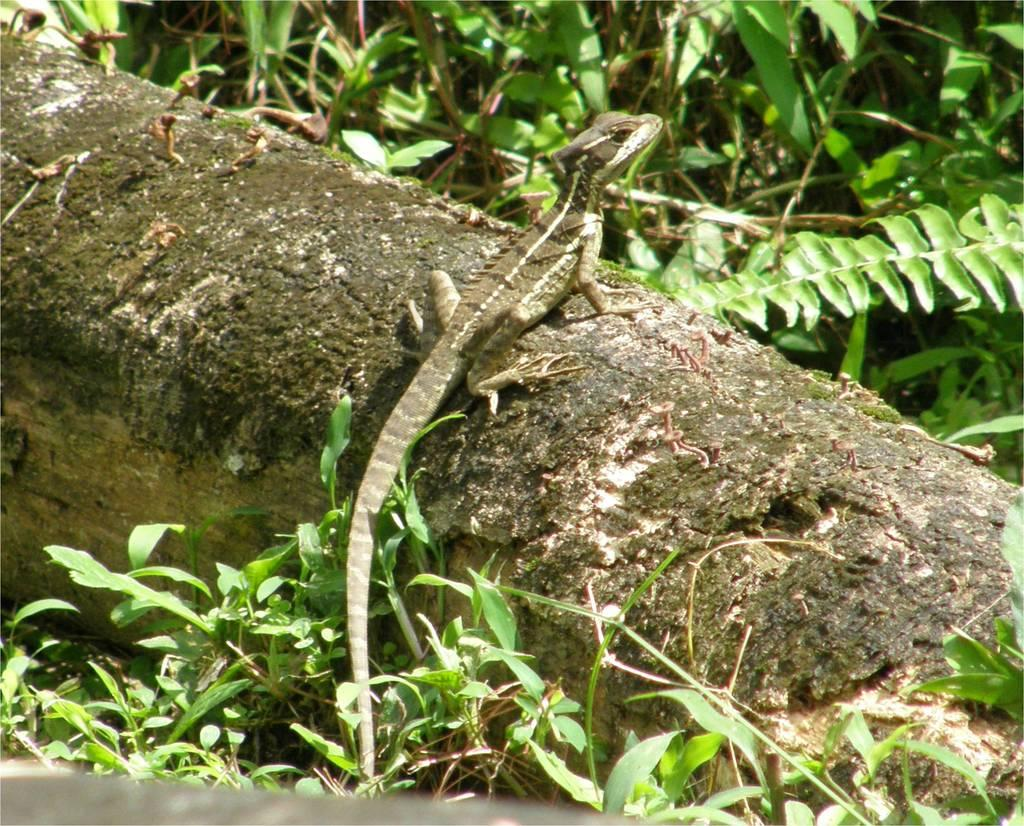What type of object is in the image that is typically used for storage? There is a wooden trunk in the image, which is commonly used for storage. What type of animal can be seen in the image? There is a lizard visible in the image. What type of plant material is present in the image? Leaves and stems are visible in the image. What type of swing can be seen in the image? There is no swing present in the image. 